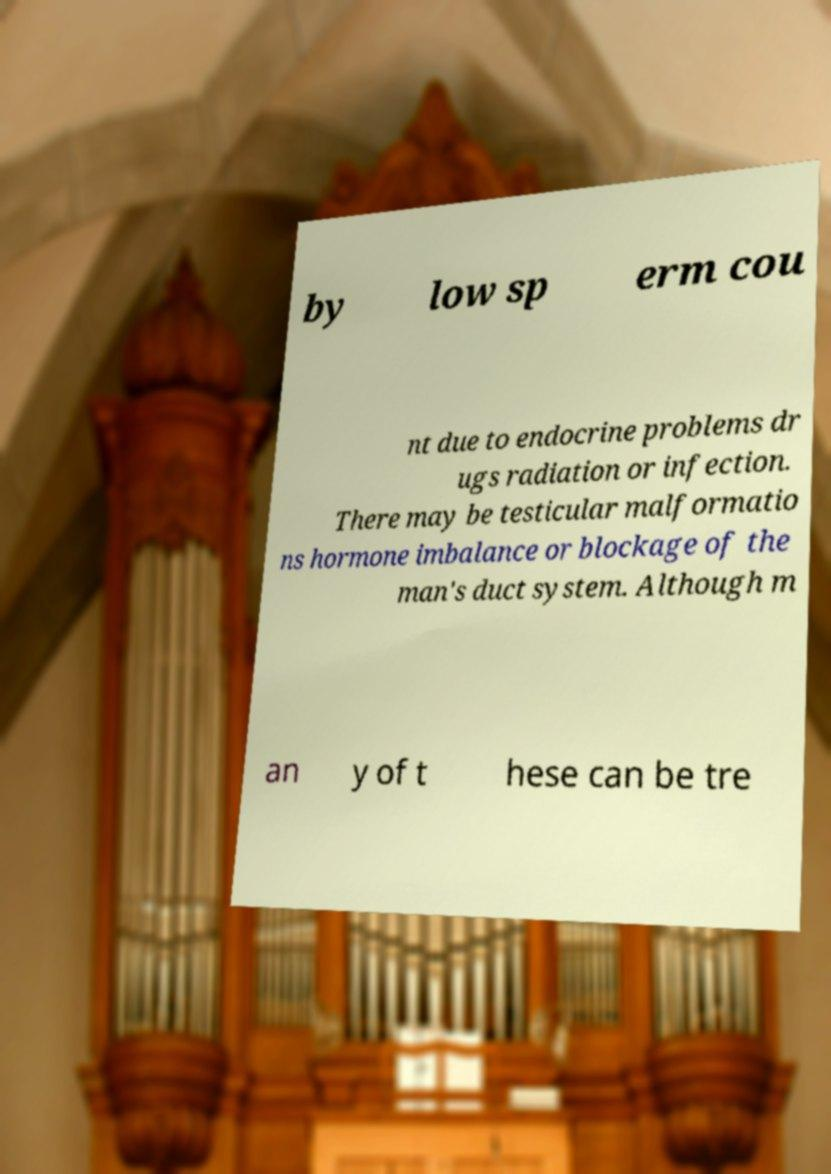Can you read and provide the text displayed in the image?This photo seems to have some interesting text. Can you extract and type it out for me? by low sp erm cou nt due to endocrine problems dr ugs radiation or infection. There may be testicular malformatio ns hormone imbalance or blockage of the man's duct system. Although m an y of t hese can be tre 